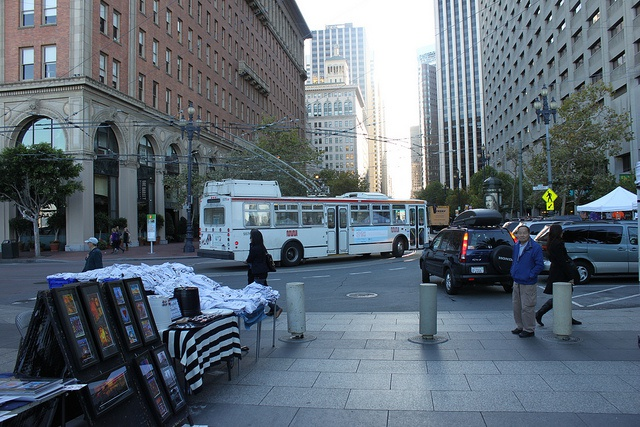Describe the objects in this image and their specific colors. I can see bus in gray, lightblue, and black tones, car in gray, black, blue, and navy tones, car in gray, black, blue, and navy tones, people in gray, navy, black, and darkblue tones, and people in gray, black, and blue tones in this image. 